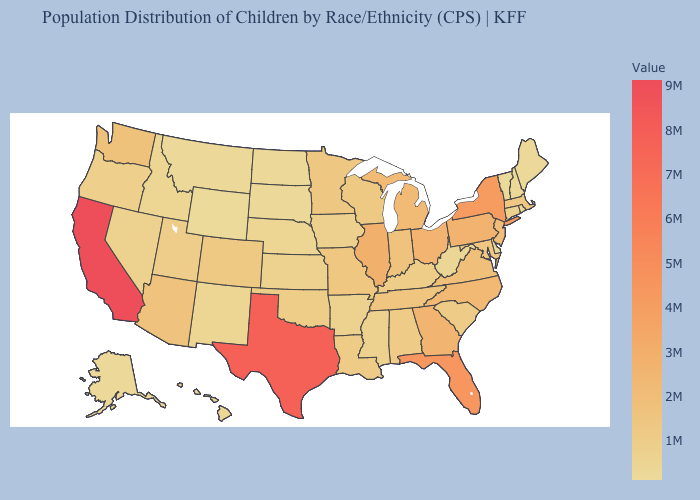Does Pennsylvania have the lowest value in the USA?
Give a very brief answer. No. Among the states that border Colorado , does Wyoming have the lowest value?
Write a very short answer. Yes. Does South Dakota have a higher value than Illinois?
Keep it brief. No. Among the states that border New Hampshire , which have the lowest value?
Answer briefly. Vermont. Does Illinois have the highest value in the MidWest?
Be succinct. Yes. Does Louisiana have a lower value than Florida?
Keep it brief. Yes. 